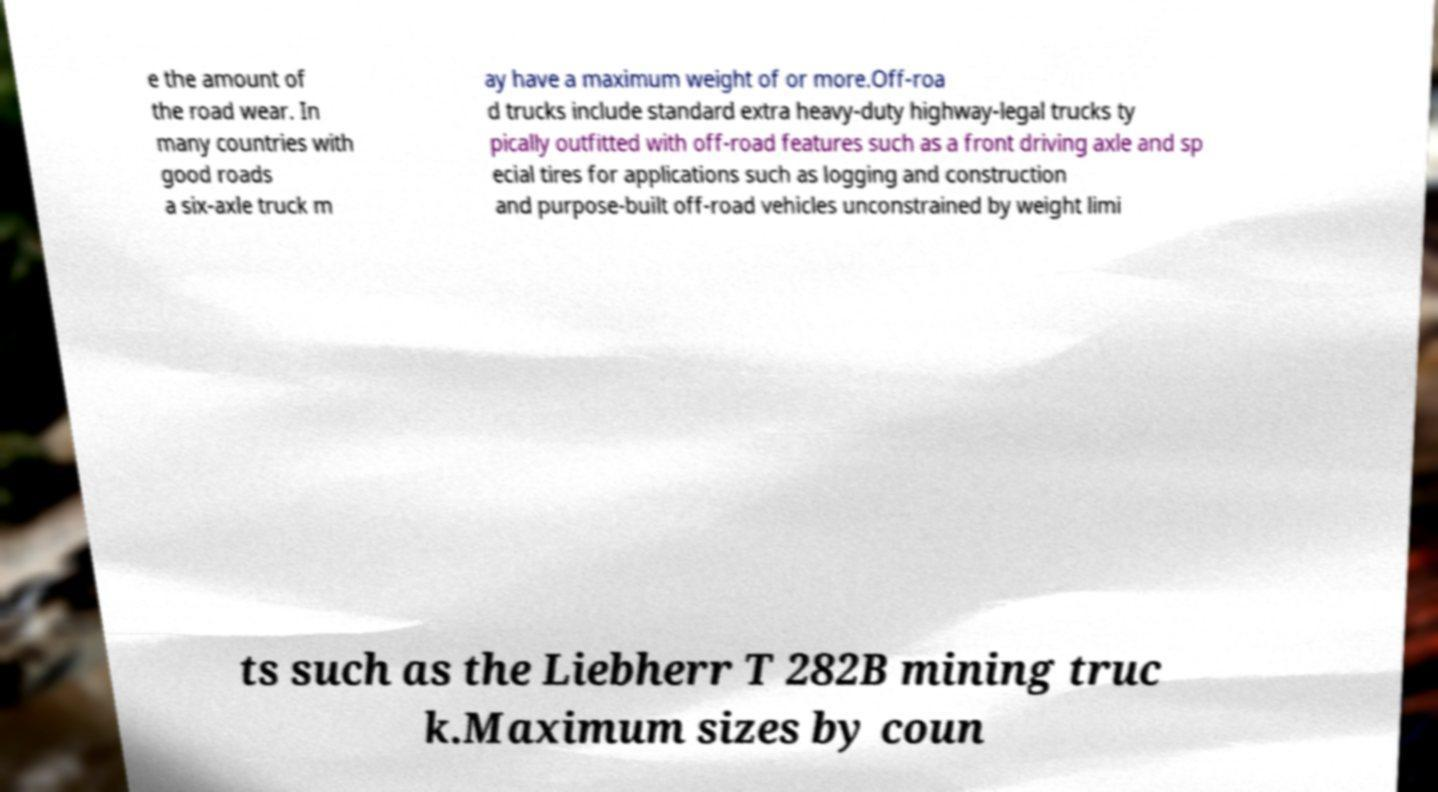Please identify and transcribe the text found in this image. e the amount of the road wear. In many countries with good roads a six-axle truck m ay have a maximum weight of or more.Off-roa d trucks include standard extra heavy-duty highway-legal trucks ty pically outfitted with off-road features such as a front driving axle and sp ecial tires for applications such as logging and construction and purpose-built off-road vehicles unconstrained by weight limi ts such as the Liebherr T 282B mining truc k.Maximum sizes by coun 